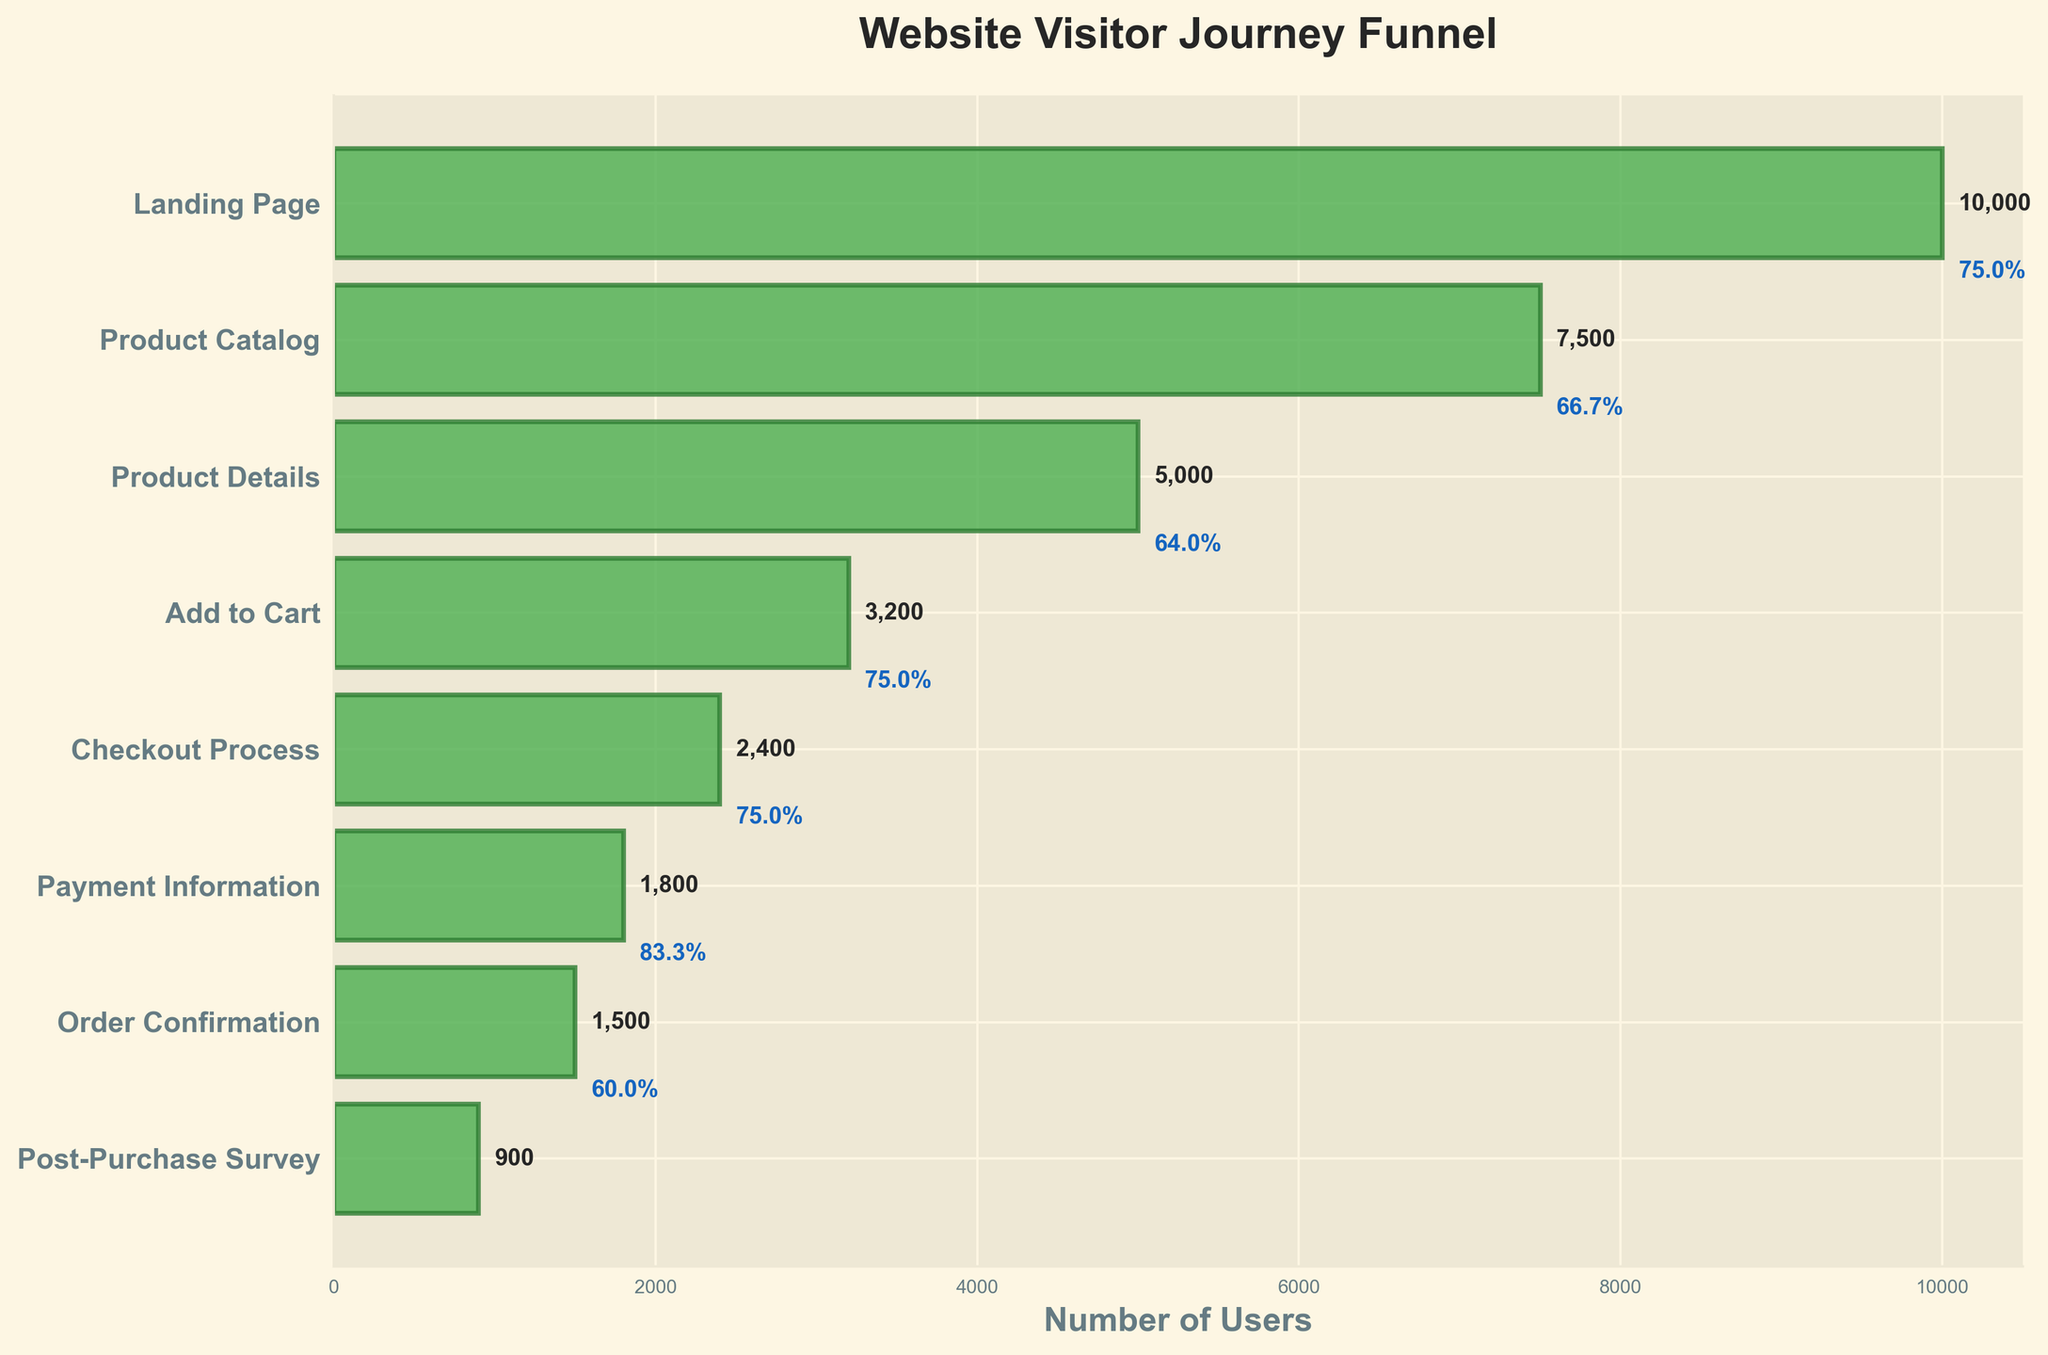What's the title of the funnel chart? The title of the chart is usually found at the top and it's labeled clearly. In this case, it's written in bold and is 'Website Visitor Journey Funnel'.
Answer: Website Visitor Journey Funnel What is the number of users who landed on the landing page? The leftmost value given in the funnel chart corresponds to the number of users at the first stage, which in this case is the landing page.
Answer: 10000 How many users completed the Post-Purchase Survey? The number of users who completed the Post-Purchase Survey is listed as the last data point in the funnel chart.
Answer: 900 What percentage of users who added items to their cart completed the checkout process? To find the percentage, you divide the number of users in the checkout process (2400) by the number of users who added items to the cart (3200) and then multiply by 100: (2400 / 3200) * 100.
Answer: 75% What’s the difference in users between the Checkout Process and the Payment Information step? Subtract the number of users in the Payment Information step (1800) from the number of users in the Checkout Process step (2400): 2400 - 1800.
Answer: 600 How many users moved from Product Catalog to Product Details? Subtract the users in the Product Details step (5000) from those in the Product Catalog step (7500): 7500 - 5000.
Answer: 2500 Which step in the funnel had the highest drop-off rate? Compare the drop-offs between each consecutive step. The largest drop-off appears between the Landing Page (10000) to Product Catalog (7500): 10000 - 7500.
Answer: Landing Page to Product Catalog What is the conversion rate from landing page to order confirmation? The conversion rate is calculated by dividing the number of users who reached the order confirmation step (1500) by those who landed on the page (10000) and multiplying by 100 to convert to percentage: (1500 / 10000) * 100.
Answer: 15% How many total steps are there in the funnel including the landing page? Count each unique step listed on the y-axis of the funnel chart.
Answer: 8 If 1500 users reached the Order Confirmation step, what percentage of them completed the Post-Purchase Survey? Calculate the percentage by dividing the number of users who completed the Post-Purchase Survey (900) by the number of users who reached the Order Confirmation step (1500) and then multiplying by 100: (900 / 1500) * 100.
Answer: 60% 